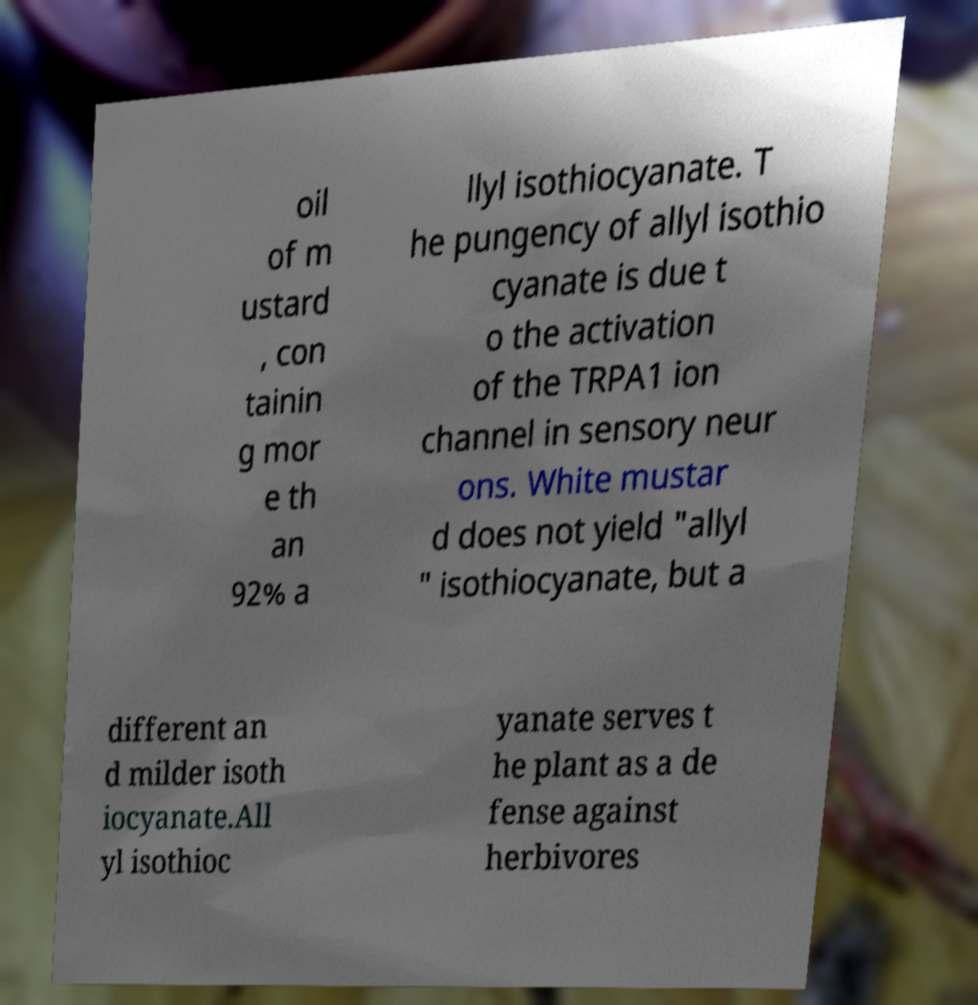Can you read and provide the text displayed in the image?This photo seems to have some interesting text. Can you extract and type it out for me? oil of m ustard , con tainin g mor e th an 92% a llyl isothiocyanate. T he pungency of allyl isothio cyanate is due t o the activation of the TRPA1 ion channel in sensory neur ons. White mustar d does not yield "allyl " isothiocyanate, but a different an d milder isoth iocyanate.All yl isothioc yanate serves t he plant as a de fense against herbivores 